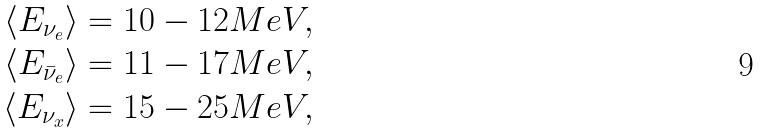<formula> <loc_0><loc_0><loc_500><loc_500>\langle E _ { \nu _ { e } } \rangle = 1 0 - 1 2 M e V , \\ \langle E _ { \bar { \nu } _ { e } } \rangle = 1 1 - 1 7 M e V , \\ \langle E _ { \nu _ { x } } \rangle = 1 5 - 2 5 M e V ,</formula> 